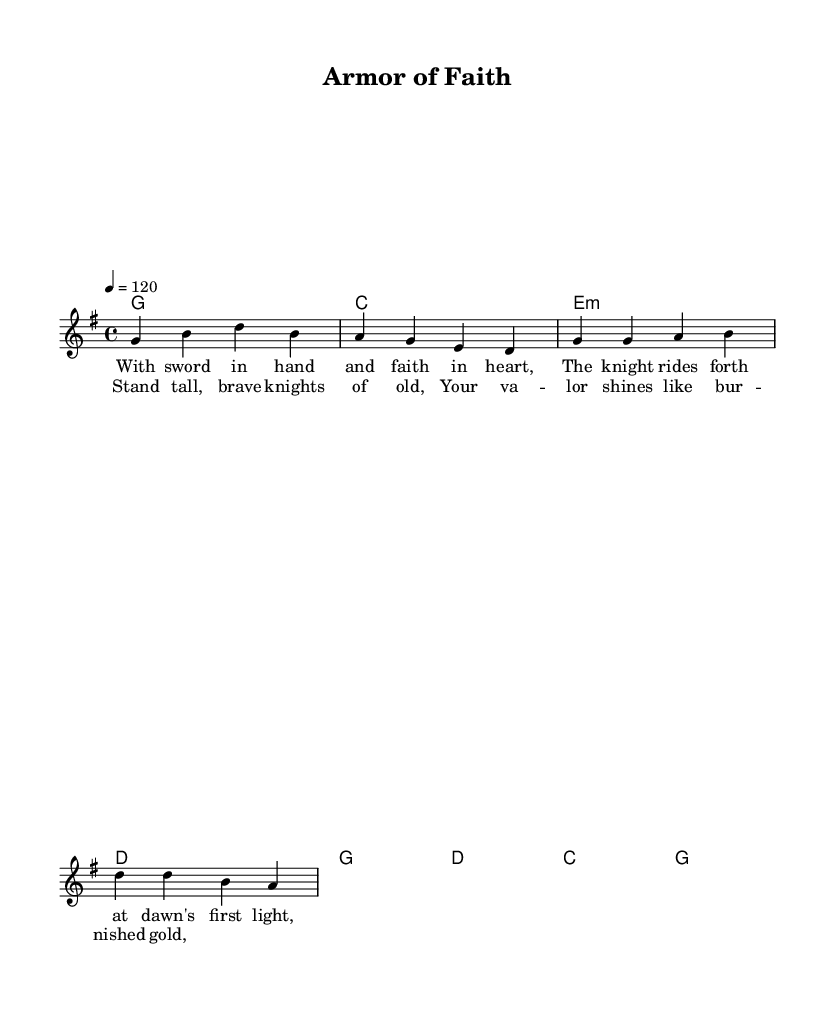What is the key signature of this music? The key signature is G major, indicated by one sharp (F#), which is often found at the beginning of the staff.
Answer: G major What is the time signature of this piece? The time signature is 4/4, represented as a fraction (4 over 4) at the beginning of the sheet music, indicating four beats in a measure.
Answer: 4/4 What is the tempo marking given in the music? The tempo is set at quarter note equals 120 beats per minute, which is shown at the start of the score.
Answer: 120 How many measures are in the verse section? The verse section consists of two measures, which can be counted from the melody, totaling two distinct phrases.
Answer: 2 What is the first note of the melody? The first note of the melody is G, as indicated at the beginning of the melody line.
Answer: G What does the chorus suggest about the knights? The chorus celebrates their bravery and valor, as indicated by the lyrics "Stand tall, brave knights of old."
Answer: Valor What chord follows the melody in the first measure? The first measure is accompanied by a G major chord, as indicated by the notation below the melody line.
Answer: G 